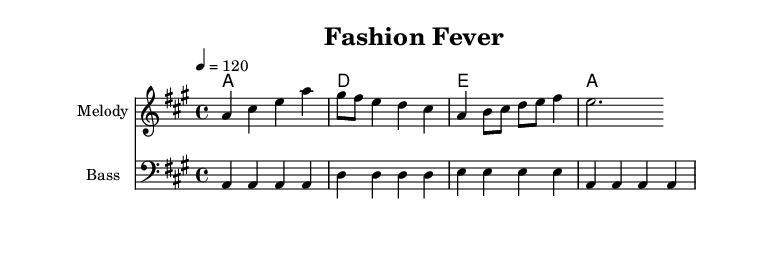What is the key signature of this music? The key signature is A major, which has three sharps: F#, C#, and G#. This can be identified at the beginning of the staff where the sharps are placed before the notes.
Answer: A major What is the time signature of this music? The time signature is 4/4, which indicates there are four beats in each measure and the quarter note receives one beat. This is shown clearly in the beginning section of the score.
Answer: 4/4 What is the tempo marking for this music? The tempo is marked at quarter note equals 120. This indicates the speed at which the piece should be played and can be found at the beginning of the score.
Answer: 120 How many measures are there in the melody? The melody is made up of eight measures, which can be counted by looking for the vertical lines that separate each measure in the sheet music.
Answer: Eight What types of chords are used in the harmonic progression? The harmonic progression features major chords: A major, D major, and E major. This can be determined by looking at the chord symbols in the chord section.
Answer: Major How many notes are played in the bass line during the first measure? The bass line in the first measure plays four notes, which can be seen by counting each note in that measure.
Answer: Four What is the rhythmic value of the first note in the melody? The first note in the melody is an A note, and its rhythmic value is a quarter note, as indicated by the notehead and stem in the notation.
Answer: Quarter note 